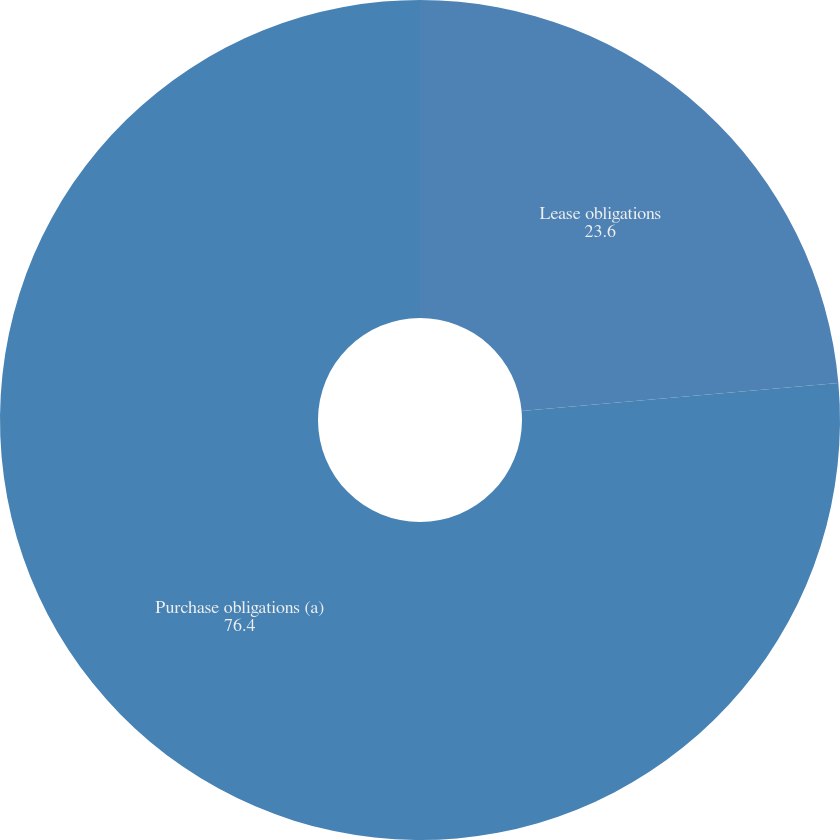<chart> <loc_0><loc_0><loc_500><loc_500><pie_chart><fcel>Lease obligations<fcel>Purchase obligations (a)<nl><fcel>23.6%<fcel>76.4%<nl></chart> 